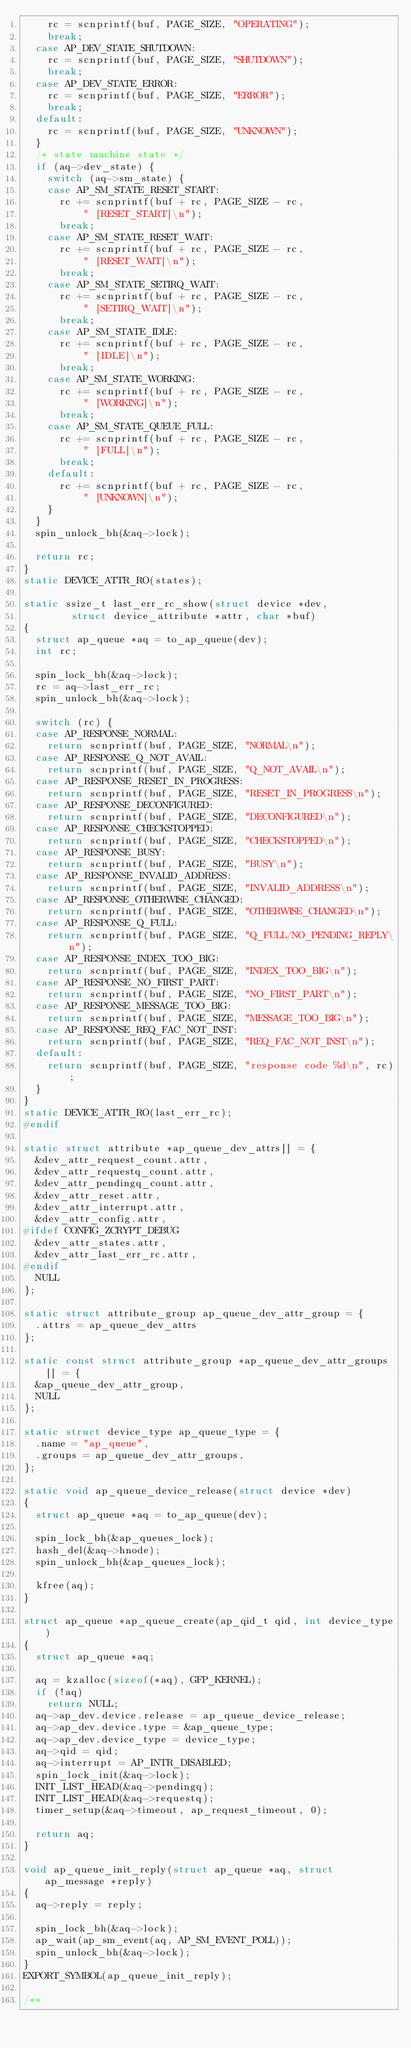<code> <loc_0><loc_0><loc_500><loc_500><_C_>		rc = scnprintf(buf, PAGE_SIZE, "OPERATING");
		break;
	case AP_DEV_STATE_SHUTDOWN:
		rc = scnprintf(buf, PAGE_SIZE, "SHUTDOWN");
		break;
	case AP_DEV_STATE_ERROR:
		rc = scnprintf(buf, PAGE_SIZE, "ERROR");
		break;
	default:
		rc = scnprintf(buf, PAGE_SIZE, "UNKNOWN");
	}
	/* state machine state */
	if (aq->dev_state) {
		switch (aq->sm_state) {
		case AP_SM_STATE_RESET_START:
			rc += scnprintf(buf + rc, PAGE_SIZE - rc,
					" [RESET_START]\n");
			break;
		case AP_SM_STATE_RESET_WAIT:
			rc += scnprintf(buf + rc, PAGE_SIZE - rc,
					" [RESET_WAIT]\n");
			break;
		case AP_SM_STATE_SETIRQ_WAIT:
			rc += scnprintf(buf + rc, PAGE_SIZE - rc,
					" [SETIRQ_WAIT]\n");
			break;
		case AP_SM_STATE_IDLE:
			rc += scnprintf(buf + rc, PAGE_SIZE - rc,
					" [IDLE]\n");
			break;
		case AP_SM_STATE_WORKING:
			rc += scnprintf(buf + rc, PAGE_SIZE - rc,
					" [WORKING]\n");
			break;
		case AP_SM_STATE_QUEUE_FULL:
			rc += scnprintf(buf + rc, PAGE_SIZE - rc,
					" [FULL]\n");
			break;
		default:
			rc += scnprintf(buf + rc, PAGE_SIZE - rc,
					" [UNKNOWN]\n");
		}
	}
	spin_unlock_bh(&aq->lock);

	return rc;
}
static DEVICE_ATTR_RO(states);

static ssize_t last_err_rc_show(struct device *dev,
				struct device_attribute *attr, char *buf)
{
	struct ap_queue *aq = to_ap_queue(dev);
	int rc;

	spin_lock_bh(&aq->lock);
	rc = aq->last_err_rc;
	spin_unlock_bh(&aq->lock);

	switch (rc) {
	case AP_RESPONSE_NORMAL:
		return scnprintf(buf, PAGE_SIZE, "NORMAL\n");
	case AP_RESPONSE_Q_NOT_AVAIL:
		return scnprintf(buf, PAGE_SIZE, "Q_NOT_AVAIL\n");
	case AP_RESPONSE_RESET_IN_PROGRESS:
		return scnprintf(buf, PAGE_SIZE, "RESET_IN_PROGRESS\n");
	case AP_RESPONSE_DECONFIGURED:
		return scnprintf(buf, PAGE_SIZE, "DECONFIGURED\n");
	case AP_RESPONSE_CHECKSTOPPED:
		return scnprintf(buf, PAGE_SIZE, "CHECKSTOPPED\n");
	case AP_RESPONSE_BUSY:
		return scnprintf(buf, PAGE_SIZE, "BUSY\n");
	case AP_RESPONSE_INVALID_ADDRESS:
		return scnprintf(buf, PAGE_SIZE, "INVALID_ADDRESS\n");
	case AP_RESPONSE_OTHERWISE_CHANGED:
		return scnprintf(buf, PAGE_SIZE, "OTHERWISE_CHANGED\n");
	case AP_RESPONSE_Q_FULL:
		return scnprintf(buf, PAGE_SIZE, "Q_FULL/NO_PENDING_REPLY\n");
	case AP_RESPONSE_INDEX_TOO_BIG:
		return scnprintf(buf, PAGE_SIZE, "INDEX_TOO_BIG\n");
	case AP_RESPONSE_NO_FIRST_PART:
		return scnprintf(buf, PAGE_SIZE, "NO_FIRST_PART\n");
	case AP_RESPONSE_MESSAGE_TOO_BIG:
		return scnprintf(buf, PAGE_SIZE, "MESSAGE_TOO_BIG\n");
	case AP_RESPONSE_REQ_FAC_NOT_INST:
		return scnprintf(buf, PAGE_SIZE, "REQ_FAC_NOT_INST\n");
	default:
		return scnprintf(buf, PAGE_SIZE, "response code %d\n", rc);
	}
}
static DEVICE_ATTR_RO(last_err_rc);
#endif

static struct attribute *ap_queue_dev_attrs[] = {
	&dev_attr_request_count.attr,
	&dev_attr_requestq_count.attr,
	&dev_attr_pendingq_count.attr,
	&dev_attr_reset.attr,
	&dev_attr_interrupt.attr,
	&dev_attr_config.attr,
#ifdef CONFIG_ZCRYPT_DEBUG
	&dev_attr_states.attr,
	&dev_attr_last_err_rc.attr,
#endif
	NULL
};

static struct attribute_group ap_queue_dev_attr_group = {
	.attrs = ap_queue_dev_attrs
};

static const struct attribute_group *ap_queue_dev_attr_groups[] = {
	&ap_queue_dev_attr_group,
	NULL
};

static struct device_type ap_queue_type = {
	.name = "ap_queue",
	.groups = ap_queue_dev_attr_groups,
};

static void ap_queue_device_release(struct device *dev)
{
	struct ap_queue *aq = to_ap_queue(dev);

	spin_lock_bh(&ap_queues_lock);
	hash_del(&aq->hnode);
	spin_unlock_bh(&ap_queues_lock);

	kfree(aq);
}

struct ap_queue *ap_queue_create(ap_qid_t qid, int device_type)
{
	struct ap_queue *aq;

	aq = kzalloc(sizeof(*aq), GFP_KERNEL);
	if (!aq)
		return NULL;
	aq->ap_dev.device.release = ap_queue_device_release;
	aq->ap_dev.device.type = &ap_queue_type;
	aq->ap_dev.device_type = device_type;
	aq->qid = qid;
	aq->interrupt = AP_INTR_DISABLED;
	spin_lock_init(&aq->lock);
	INIT_LIST_HEAD(&aq->pendingq);
	INIT_LIST_HEAD(&aq->requestq);
	timer_setup(&aq->timeout, ap_request_timeout, 0);

	return aq;
}

void ap_queue_init_reply(struct ap_queue *aq, struct ap_message *reply)
{
	aq->reply = reply;

	spin_lock_bh(&aq->lock);
	ap_wait(ap_sm_event(aq, AP_SM_EVENT_POLL));
	spin_unlock_bh(&aq->lock);
}
EXPORT_SYMBOL(ap_queue_init_reply);

/**</code> 